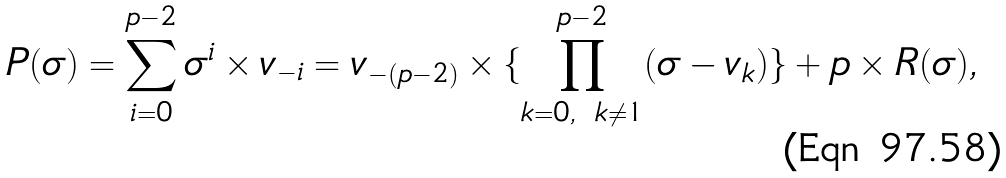<formula> <loc_0><loc_0><loc_500><loc_500>P ( \sigma ) = \sum _ { i = 0 } ^ { p - 2 } \sigma ^ { i } \times v _ { - i } = v _ { - ( p - 2 ) } \times \{ \prod _ { k = 0 , \ k \not = 1 } ^ { p - 2 } ( \sigma - v _ { k } ) \} + p \times R ( \sigma ) ,</formula> 